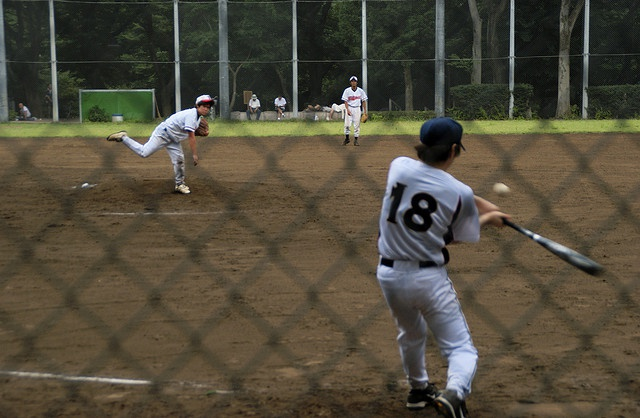Describe the objects in this image and their specific colors. I can see people in gray, black, and darkgray tones, people in gray, lightgray, darkgray, and black tones, people in gray, lightgray, darkgray, and black tones, baseball bat in gray, black, and darkgray tones, and people in gray, black, darkgray, and darkgreen tones in this image. 